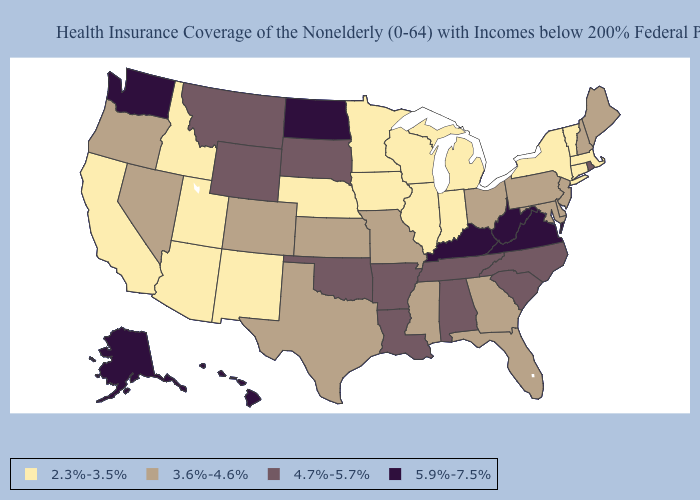What is the lowest value in states that border Washington?
Quick response, please. 2.3%-3.5%. Among the states that border Colorado , does Arizona have the highest value?
Write a very short answer. No. Does Nevada have a higher value than Michigan?
Be succinct. Yes. What is the value of Michigan?
Quick response, please. 2.3%-3.5%. What is the value of Georgia?
Keep it brief. 3.6%-4.6%. Does New Mexico have the lowest value in the West?
Write a very short answer. Yes. Which states have the lowest value in the USA?
Quick response, please. Arizona, California, Connecticut, Idaho, Illinois, Indiana, Iowa, Massachusetts, Michigan, Minnesota, Nebraska, New Mexico, New York, Utah, Vermont, Wisconsin. Which states have the lowest value in the USA?
Keep it brief. Arizona, California, Connecticut, Idaho, Illinois, Indiana, Iowa, Massachusetts, Michigan, Minnesota, Nebraska, New Mexico, New York, Utah, Vermont, Wisconsin. Does the map have missing data?
Answer briefly. No. How many symbols are there in the legend?
Be succinct. 4. What is the value of Montana?
Write a very short answer. 4.7%-5.7%. Name the states that have a value in the range 2.3%-3.5%?
Be succinct. Arizona, California, Connecticut, Idaho, Illinois, Indiana, Iowa, Massachusetts, Michigan, Minnesota, Nebraska, New Mexico, New York, Utah, Vermont, Wisconsin. Name the states that have a value in the range 3.6%-4.6%?
Write a very short answer. Colorado, Delaware, Florida, Georgia, Kansas, Maine, Maryland, Mississippi, Missouri, Nevada, New Hampshire, New Jersey, Ohio, Oregon, Pennsylvania, Texas. Name the states that have a value in the range 5.9%-7.5%?
Answer briefly. Alaska, Hawaii, Kentucky, North Dakota, Virginia, Washington, West Virginia. Which states have the lowest value in the MidWest?
Concise answer only. Illinois, Indiana, Iowa, Michigan, Minnesota, Nebraska, Wisconsin. 